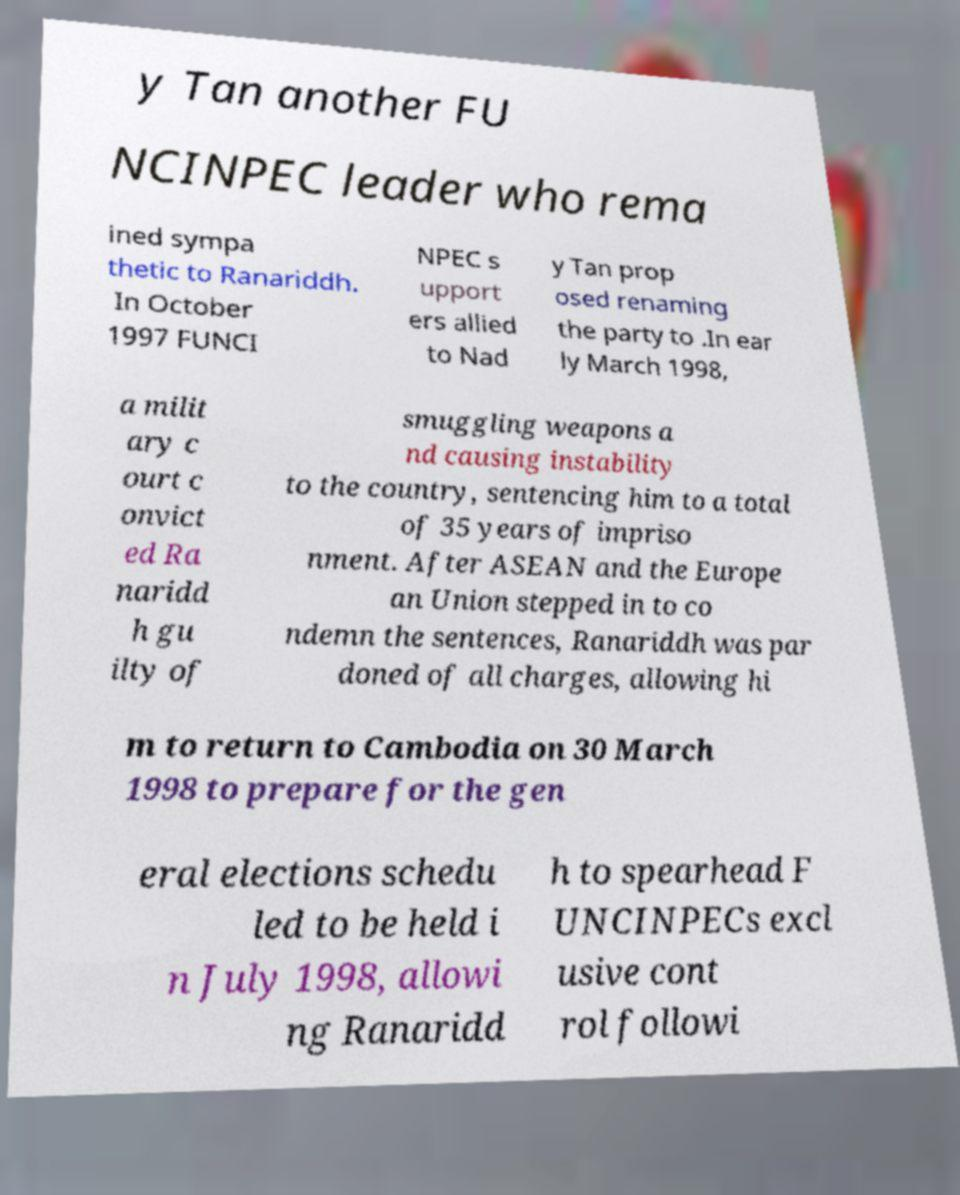What messages or text are displayed in this image? I need them in a readable, typed format. y Tan another FU NCINPEC leader who rema ined sympa thetic to Ranariddh. In October 1997 FUNCI NPEC s upport ers allied to Nad y Tan prop osed renaming the party to .In ear ly March 1998, a milit ary c ourt c onvict ed Ra naridd h gu ilty of smuggling weapons a nd causing instability to the country, sentencing him to a total of 35 years of impriso nment. After ASEAN and the Europe an Union stepped in to co ndemn the sentences, Ranariddh was par doned of all charges, allowing hi m to return to Cambodia on 30 March 1998 to prepare for the gen eral elections schedu led to be held i n July 1998, allowi ng Ranaridd h to spearhead F UNCINPECs excl usive cont rol followi 